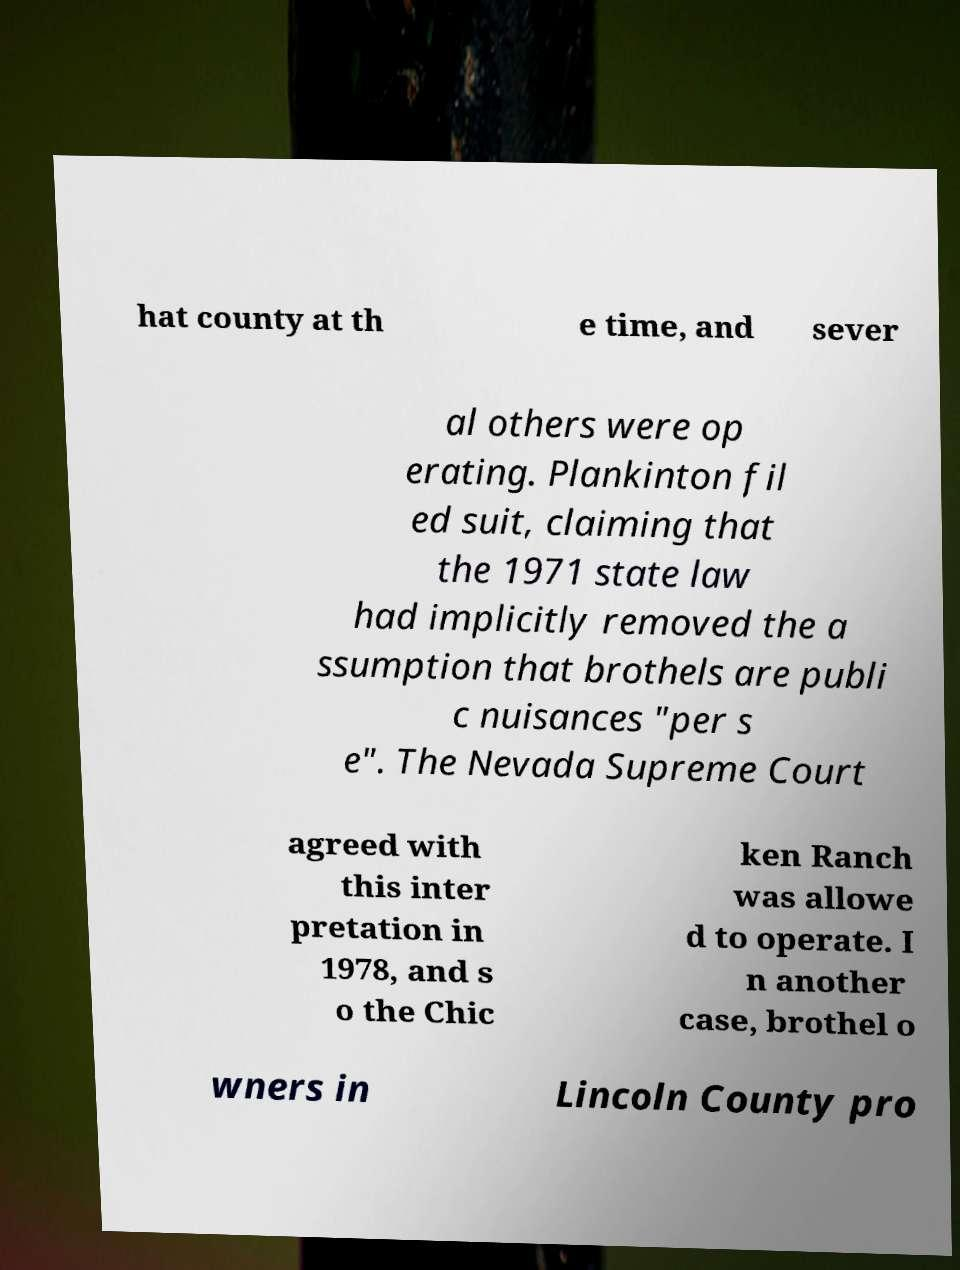Please identify and transcribe the text found in this image. hat county at th e time, and sever al others were op erating. Plankinton fil ed suit, claiming that the 1971 state law had implicitly removed the a ssumption that brothels are publi c nuisances "per s e". The Nevada Supreme Court agreed with this inter pretation in 1978, and s o the Chic ken Ranch was allowe d to operate. I n another case, brothel o wners in Lincoln County pro 